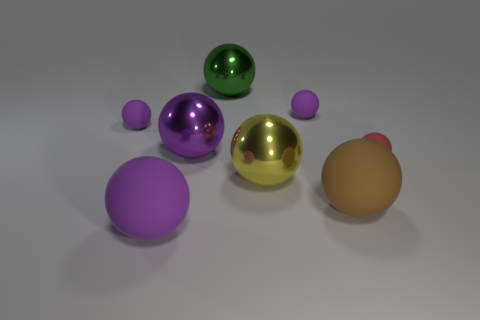Subtract all big balls. How many balls are left? 3 Subtract all purple spheres. How many were subtracted if there are3purple spheres left? 1 Subtract all blue balls. Subtract all brown cubes. How many balls are left? 8 Subtract all red cylinders. How many green spheres are left? 1 Subtract all brown spheres. Subtract all green metallic things. How many objects are left? 6 Add 2 rubber balls. How many rubber balls are left? 7 Add 4 rubber objects. How many rubber objects exist? 9 Add 2 big yellow shiny spheres. How many objects exist? 10 Subtract all red spheres. How many spheres are left? 7 Subtract 1 brown spheres. How many objects are left? 7 